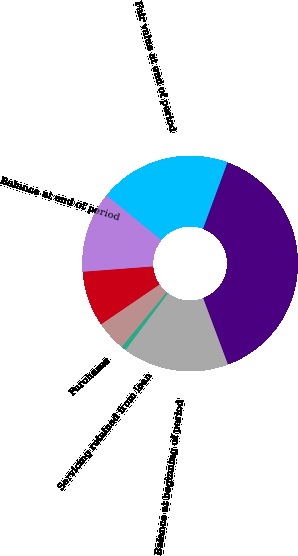Convert chart. <chart><loc_0><loc_0><loc_500><loc_500><pie_chart><fcel>in millions<fcel>Balance at beginning of period<fcel>Servicing retained from loan<fcel>Purchases<fcel>Amortization<fcel>Balance at end of period<fcel>Fair value at end of period<nl><fcel>38.69%<fcel>15.91%<fcel>0.73%<fcel>4.53%<fcel>8.32%<fcel>12.12%<fcel>19.71%<nl></chart> 